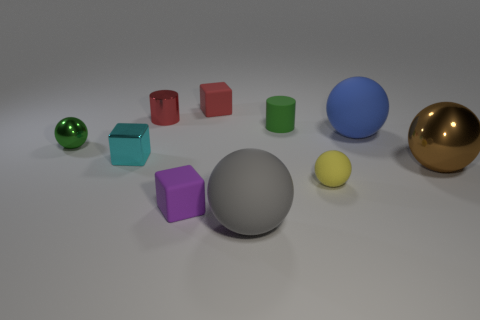Subtract all green balls. How many balls are left? 4 Subtract all cubes. How many objects are left? 7 Subtract all blue matte spheres. How many spheres are left? 4 Subtract 2 blocks. How many blocks are left? 1 Add 2 tiny red cubes. How many tiny red cubes are left? 3 Add 6 large yellow shiny spheres. How many large yellow shiny spheres exist? 6 Subtract 0 gray cylinders. How many objects are left? 10 Subtract all blue blocks. Subtract all gray balls. How many blocks are left? 3 Subtract all cyan balls. How many purple cylinders are left? 0 Subtract all small purple metal balls. Subtract all rubber things. How many objects are left? 4 